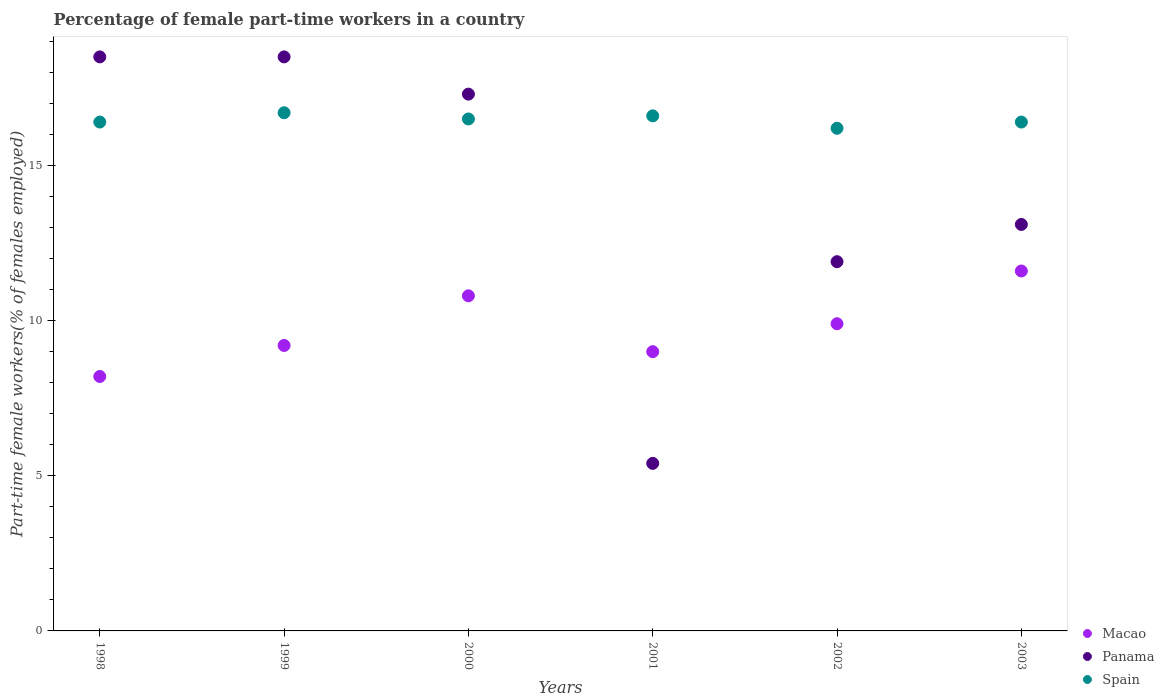How many different coloured dotlines are there?
Offer a very short reply. 3. Is the number of dotlines equal to the number of legend labels?
Your answer should be compact. Yes. What is the percentage of female part-time workers in Macao in 2003?
Offer a terse response. 11.6. Across all years, what is the maximum percentage of female part-time workers in Spain?
Your answer should be compact. 16.7. Across all years, what is the minimum percentage of female part-time workers in Macao?
Make the answer very short. 8.2. In which year was the percentage of female part-time workers in Macao maximum?
Provide a short and direct response. 2003. In which year was the percentage of female part-time workers in Spain minimum?
Provide a short and direct response. 2002. What is the total percentage of female part-time workers in Macao in the graph?
Your answer should be compact. 58.7. What is the difference between the percentage of female part-time workers in Panama in 2002 and that in 2003?
Make the answer very short. -1.2. What is the difference between the percentage of female part-time workers in Panama in 2000 and the percentage of female part-time workers in Macao in 2001?
Offer a very short reply. 8.3. What is the average percentage of female part-time workers in Panama per year?
Offer a terse response. 14.12. In the year 2002, what is the difference between the percentage of female part-time workers in Panama and percentage of female part-time workers in Macao?
Give a very brief answer. 2. What is the ratio of the percentage of female part-time workers in Panama in 2002 to that in 2003?
Provide a short and direct response. 0.91. What is the difference between the highest and the second highest percentage of female part-time workers in Macao?
Give a very brief answer. 0.8. What is the difference between the highest and the lowest percentage of female part-time workers in Panama?
Give a very brief answer. 13.1. In how many years, is the percentage of female part-time workers in Spain greater than the average percentage of female part-time workers in Spain taken over all years?
Offer a terse response. 3. Is the sum of the percentage of female part-time workers in Spain in 1999 and 2002 greater than the maximum percentage of female part-time workers in Panama across all years?
Ensure brevity in your answer.  Yes. Where does the legend appear in the graph?
Your answer should be very brief. Bottom right. How many legend labels are there?
Provide a succinct answer. 3. What is the title of the graph?
Offer a terse response. Percentage of female part-time workers in a country. Does "Spain" appear as one of the legend labels in the graph?
Offer a very short reply. Yes. What is the label or title of the X-axis?
Make the answer very short. Years. What is the label or title of the Y-axis?
Offer a very short reply. Part-time female workers(% of females employed). What is the Part-time female workers(% of females employed) in Macao in 1998?
Provide a short and direct response. 8.2. What is the Part-time female workers(% of females employed) in Panama in 1998?
Give a very brief answer. 18.5. What is the Part-time female workers(% of females employed) in Spain in 1998?
Ensure brevity in your answer.  16.4. What is the Part-time female workers(% of females employed) in Macao in 1999?
Provide a succinct answer. 9.2. What is the Part-time female workers(% of females employed) in Spain in 1999?
Make the answer very short. 16.7. What is the Part-time female workers(% of females employed) of Macao in 2000?
Ensure brevity in your answer.  10.8. What is the Part-time female workers(% of females employed) of Panama in 2000?
Give a very brief answer. 17.3. What is the Part-time female workers(% of females employed) of Spain in 2000?
Provide a succinct answer. 16.5. What is the Part-time female workers(% of females employed) in Macao in 2001?
Offer a terse response. 9. What is the Part-time female workers(% of females employed) in Panama in 2001?
Offer a terse response. 5.4. What is the Part-time female workers(% of females employed) of Spain in 2001?
Keep it short and to the point. 16.6. What is the Part-time female workers(% of females employed) in Macao in 2002?
Give a very brief answer. 9.9. What is the Part-time female workers(% of females employed) of Panama in 2002?
Keep it short and to the point. 11.9. What is the Part-time female workers(% of females employed) in Spain in 2002?
Provide a succinct answer. 16.2. What is the Part-time female workers(% of females employed) in Macao in 2003?
Your answer should be compact. 11.6. What is the Part-time female workers(% of females employed) in Panama in 2003?
Your answer should be compact. 13.1. What is the Part-time female workers(% of females employed) in Spain in 2003?
Provide a short and direct response. 16.4. Across all years, what is the maximum Part-time female workers(% of females employed) of Macao?
Make the answer very short. 11.6. Across all years, what is the maximum Part-time female workers(% of females employed) in Panama?
Give a very brief answer. 18.5. Across all years, what is the maximum Part-time female workers(% of females employed) in Spain?
Your answer should be compact. 16.7. Across all years, what is the minimum Part-time female workers(% of females employed) of Macao?
Offer a very short reply. 8.2. Across all years, what is the minimum Part-time female workers(% of females employed) in Panama?
Give a very brief answer. 5.4. Across all years, what is the minimum Part-time female workers(% of females employed) in Spain?
Offer a very short reply. 16.2. What is the total Part-time female workers(% of females employed) in Macao in the graph?
Provide a succinct answer. 58.7. What is the total Part-time female workers(% of females employed) in Panama in the graph?
Your response must be concise. 84.7. What is the total Part-time female workers(% of females employed) of Spain in the graph?
Your response must be concise. 98.8. What is the difference between the Part-time female workers(% of females employed) in Panama in 1998 and that in 2000?
Provide a succinct answer. 1.2. What is the difference between the Part-time female workers(% of females employed) in Macao in 1998 and that in 2002?
Give a very brief answer. -1.7. What is the difference between the Part-time female workers(% of females employed) in Panama in 1998 and that in 2002?
Offer a terse response. 6.6. What is the difference between the Part-time female workers(% of females employed) of Spain in 1998 and that in 2002?
Provide a short and direct response. 0.2. What is the difference between the Part-time female workers(% of females employed) in Macao in 1998 and that in 2003?
Ensure brevity in your answer.  -3.4. What is the difference between the Part-time female workers(% of females employed) in Panama in 1998 and that in 2003?
Keep it short and to the point. 5.4. What is the difference between the Part-time female workers(% of females employed) of Spain in 1998 and that in 2003?
Your answer should be compact. 0. What is the difference between the Part-time female workers(% of females employed) in Panama in 1999 and that in 2000?
Keep it short and to the point. 1.2. What is the difference between the Part-time female workers(% of females employed) of Spain in 1999 and that in 2000?
Give a very brief answer. 0.2. What is the difference between the Part-time female workers(% of females employed) in Macao in 1999 and that in 2001?
Ensure brevity in your answer.  0.2. What is the difference between the Part-time female workers(% of females employed) of Macao in 1999 and that in 2002?
Make the answer very short. -0.7. What is the difference between the Part-time female workers(% of females employed) in Panama in 1999 and that in 2002?
Ensure brevity in your answer.  6.6. What is the difference between the Part-time female workers(% of females employed) in Spain in 1999 and that in 2002?
Offer a terse response. 0.5. What is the difference between the Part-time female workers(% of females employed) in Macao in 1999 and that in 2003?
Ensure brevity in your answer.  -2.4. What is the difference between the Part-time female workers(% of females employed) in Panama in 1999 and that in 2003?
Keep it short and to the point. 5.4. What is the difference between the Part-time female workers(% of females employed) of Spain in 1999 and that in 2003?
Keep it short and to the point. 0.3. What is the difference between the Part-time female workers(% of females employed) in Macao in 2000 and that in 2001?
Ensure brevity in your answer.  1.8. What is the difference between the Part-time female workers(% of females employed) in Macao in 2000 and that in 2002?
Offer a very short reply. 0.9. What is the difference between the Part-time female workers(% of females employed) of Macao in 2000 and that in 2003?
Your answer should be very brief. -0.8. What is the difference between the Part-time female workers(% of females employed) in Macao in 2001 and that in 2002?
Offer a terse response. -0.9. What is the difference between the Part-time female workers(% of females employed) in Panama in 2001 and that in 2003?
Ensure brevity in your answer.  -7.7. What is the difference between the Part-time female workers(% of females employed) of Spain in 2002 and that in 2003?
Make the answer very short. -0.2. What is the difference between the Part-time female workers(% of females employed) of Macao in 1998 and the Part-time female workers(% of females employed) of Panama in 1999?
Provide a succinct answer. -10.3. What is the difference between the Part-time female workers(% of females employed) of Panama in 1998 and the Part-time female workers(% of females employed) of Spain in 1999?
Your answer should be compact. 1.8. What is the difference between the Part-time female workers(% of females employed) in Macao in 1998 and the Part-time female workers(% of females employed) in Panama in 2001?
Make the answer very short. 2.8. What is the difference between the Part-time female workers(% of females employed) of Macao in 1998 and the Part-time female workers(% of females employed) of Spain in 2001?
Give a very brief answer. -8.4. What is the difference between the Part-time female workers(% of females employed) in Panama in 1998 and the Part-time female workers(% of females employed) in Spain in 2001?
Your response must be concise. 1.9. What is the difference between the Part-time female workers(% of females employed) in Macao in 1998 and the Part-time female workers(% of females employed) in Spain in 2003?
Give a very brief answer. -8.2. What is the difference between the Part-time female workers(% of females employed) in Panama in 1998 and the Part-time female workers(% of females employed) in Spain in 2003?
Provide a short and direct response. 2.1. What is the difference between the Part-time female workers(% of females employed) of Macao in 1999 and the Part-time female workers(% of females employed) of Spain in 2000?
Your answer should be compact. -7.3. What is the difference between the Part-time female workers(% of females employed) of Panama in 1999 and the Part-time female workers(% of females employed) of Spain in 2000?
Ensure brevity in your answer.  2. What is the difference between the Part-time female workers(% of females employed) in Macao in 1999 and the Part-time female workers(% of females employed) in Panama in 2001?
Give a very brief answer. 3.8. What is the difference between the Part-time female workers(% of females employed) in Panama in 1999 and the Part-time female workers(% of females employed) in Spain in 2001?
Provide a short and direct response. 1.9. What is the difference between the Part-time female workers(% of females employed) of Macao in 1999 and the Part-time female workers(% of females employed) of Panama in 2002?
Offer a very short reply. -2.7. What is the difference between the Part-time female workers(% of females employed) of Macao in 1999 and the Part-time female workers(% of females employed) of Spain in 2002?
Give a very brief answer. -7. What is the difference between the Part-time female workers(% of females employed) in Panama in 1999 and the Part-time female workers(% of females employed) in Spain in 2002?
Provide a short and direct response. 2.3. What is the difference between the Part-time female workers(% of females employed) in Macao in 1999 and the Part-time female workers(% of females employed) in Panama in 2003?
Keep it short and to the point. -3.9. What is the difference between the Part-time female workers(% of females employed) in Panama in 2000 and the Part-time female workers(% of females employed) in Spain in 2001?
Provide a short and direct response. 0.7. What is the difference between the Part-time female workers(% of females employed) in Macao in 2000 and the Part-time female workers(% of females employed) in Panama in 2002?
Make the answer very short. -1.1. What is the difference between the Part-time female workers(% of females employed) in Macao in 2000 and the Part-time female workers(% of females employed) in Spain in 2002?
Make the answer very short. -5.4. What is the difference between the Part-time female workers(% of females employed) of Macao in 2000 and the Part-time female workers(% of females employed) of Panama in 2003?
Provide a short and direct response. -2.3. What is the difference between the Part-time female workers(% of females employed) of Macao in 2000 and the Part-time female workers(% of females employed) of Spain in 2003?
Provide a succinct answer. -5.6. What is the difference between the Part-time female workers(% of females employed) of Panama in 2001 and the Part-time female workers(% of females employed) of Spain in 2002?
Your answer should be very brief. -10.8. What is the difference between the Part-time female workers(% of females employed) in Panama in 2001 and the Part-time female workers(% of females employed) in Spain in 2003?
Offer a very short reply. -11. What is the difference between the Part-time female workers(% of females employed) in Macao in 2002 and the Part-time female workers(% of females employed) in Panama in 2003?
Keep it short and to the point. -3.2. What is the difference between the Part-time female workers(% of females employed) in Panama in 2002 and the Part-time female workers(% of females employed) in Spain in 2003?
Ensure brevity in your answer.  -4.5. What is the average Part-time female workers(% of females employed) in Macao per year?
Your answer should be very brief. 9.78. What is the average Part-time female workers(% of females employed) of Panama per year?
Offer a very short reply. 14.12. What is the average Part-time female workers(% of females employed) of Spain per year?
Your answer should be very brief. 16.47. In the year 1998, what is the difference between the Part-time female workers(% of females employed) in Macao and Part-time female workers(% of females employed) in Spain?
Provide a short and direct response. -8.2. In the year 1999, what is the difference between the Part-time female workers(% of females employed) of Panama and Part-time female workers(% of females employed) of Spain?
Keep it short and to the point. 1.8. In the year 2000, what is the difference between the Part-time female workers(% of females employed) of Macao and Part-time female workers(% of females employed) of Panama?
Provide a short and direct response. -6.5. In the year 2001, what is the difference between the Part-time female workers(% of females employed) of Macao and Part-time female workers(% of females employed) of Spain?
Keep it short and to the point. -7.6. In the year 2001, what is the difference between the Part-time female workers(% of females employed) of Panama and Part-time female workers(% of females employed) of Spain?
Give a very brief answer. -11.2. In the year 2002, what is the difference between the Part-time female workers(% of females employed) in Macao and Part-time female workers(% of females employed) in Spain?
Give a very brief answer. -6.3. In the year 2002, what is the difference between the Part-time female workers(% of females employed) of Panama and Part-time female workers(% of females employed) of Spain?
Provide a short and direct response. -4.3. What is the ratio of the Part-time female workers(% of females employed) in Macao in 1998 to that in 1999?
Your response must be concise. 0.89. What is the ratio of the Part-time female workers(% of females employed) in Panama in 1998 to that in 1999?
Keep it short and to the point. 1. What is the ratio of the Part-time female workers(% of females employed) of Macao in 1998 to that in 2000?
Make the answer very short. 0.76. What is the ratio of the Part-time female workers(% of females employed) of Panama in 1998 to that in 2000?
Make the answer very short. 1.07. What is the ratio of the Part-time female workers(% of females employed) of Macao in 1998 to that in 2001?
Keep it short and to the point. 0.91. What is the ratio of the Part-time female workers(% of females employed) of Panama in 1998 to that in 2001?
Make the answer very short. 3.43. What is the ratio of the Part-time female workers(% of females employed) of Spain in 1998 to that in 2001?
Provide a short and direct response. 0.99. What is the ratio of the Part-time female workers(% of females employed) in Macao in 1998 to that in 2002?
Your answer should be compact. 0.83. What is the ratio of the Part-time female workers(% of females employed) of Panama in 1998 to that in 2002?
Offer a terse response. 1.55. What is the ratio of the Part-time female workers(% of females employed) in Spain in 1998 to that in 2002?
Offer a terse response. 1.01. What is the ratio of the Part-time female workers(% of females employed) of Macao in 1998 to that in 2003?
Offer a terse response. 0.71. What is the ratio of the Part-time female workers(% of females employed) of Panama in 1998 to that in 2003?
Provide a short and direct response. 1.41. What is the ratio of the Part-time female workers(% of females employed) in Macao in 1999 to that in 2000?
Provide a succinct answer. 0.85. What is the ratio of the Part-time female workers(% of females employed) of Panama in 1999 to that in 2000?
Offer a very short reply. 1.07. What is the ratio of the Part-time female workers(% of females employed) of Spain in 1999 to that in 2000?
Your answer should be very brief. 1.01. What is the ratio of the Part-time female workers(% of females employed) in Macao in 1999 to that in 2001?
Keep it short and to the point. 1.02. What is the ratio of the Part-time female workers(% of females employed) of Panama in 1999 to that in 2001?
Your answer should be compact. 3.43. What is the ratio of the Part-time female workers(% of females employed) in Spain in 1999 to that in 2001?
Provide a succinct answer. 1.01. What is the ratio of the Part-time female workers(% of females employed) in Macao in 1999 to that in 2002?
Your response must be concise. 0.93. What is the ratio of the Part-time female workers(% of females employed) in Panama in 1999 to that in 2002?
Your answer should be very brief. 1.55. What is the ratio of the Part-time female workers(% of females employed) in Spain in 1999 to that in 2002?
Your answer should be compact. 1.03. What is the ratio of the Part-time female workers(% of females employed) of Macao in 1999 to that in 2003?
Your answer should be compact. 0.79. What is the ratio of the Part-time female workers(% of females employed) of Panama in 1999 to that in 2003?
Provide a short and direct response. 1.41. What is the ratio of the Part-time female workers(% of females employed) of Spain in 1999 to that in 2003?
Offer a very short reply. 1.02. What is the ratio of the Part-time female workers(% of females employed) of Panama in 2000 to that in 2001?
Provide a succinct answer. 3.2. What is the ratio of the Part-time female workers(% of females employed) in Spain in 2000 to that in 2001?
Provide a short and direct response. 0.99. What is the ratio of the Part-time female workers(% of females employed) in Panama in 2000 to that in 2002?
Offer a terse response. 1.45. What is the ratio of the Part-time female workers(% of females employed) of Spain in 2000 to that in 2002?
Provide a succinct answer. 1.02. What is the ratio of the Part-time female workers(% of females employed) in Macao in 2000 to that in 2003?
Provide a short and direct response. 0.93. What is the ratio of the Part-time female workers(% of females employed) in Panama in 2000 to that in 2003?
Make the answer very short. 1.32. What is the ratio of the Part-time female workers(% of females employed) of Spain in 2000 to that in 2003?
Offer a terse response. 1.01. What is the ratio of the Part-time female workers(% of females employed) in Panama in 2001 to that in 2002?
Your answer should be compact. 0.45. What is the ratio of the Part-time female workers(% of females employed) in Spain in 2001 to that in 2002?
Ensure brevity in your answer.  1.02. What is the ratio of the Part-time female workers(% of females employed) in Macao in 2001 to that in 2003?
Your answer should be compact. 0.78. What is the ratio of the Part-time female workers(% of females employed) in Panama in 2001 to that in 2003?
Provide a succinct answer. 0.41. What is the ratio of the Part-time female workers(% of females employed) in Spain in 2001 to that in 2003?
Provide a short and direct response. 1.01. What is the ratio of the Part-time female workers(% of females employed) in Macao in 2002 to that in 2003?
Keep it short and to the point. 0.85. What is the ratio of the Part-time female workers(% of females employed) of Panama in 2002 to that in 2003?
Keep it short and to the point. 0.91. What is the difference between the highest and the second highest Part-time female workers(% of females employed) in Macao?
Provide a short and direct response. 0.8. What is the difference between the highest and the second highest Part-time female workers(% of females employed) in Panama?
Provide a succinct answer. 0. What is the difference between the highest and the lowest Part-time female workers(% of females employed) in Macao?
Offer a very short reply. 3.4. What is the difference between the highest and the lowest Part-time female workers(% of females employed) in Panama?
Provide a short and direct response. 13.1. What is the difference between the highest and the lowest Part-time female workers(% of females employed) in Spain?
Provide a short and direct response. 0.5. 